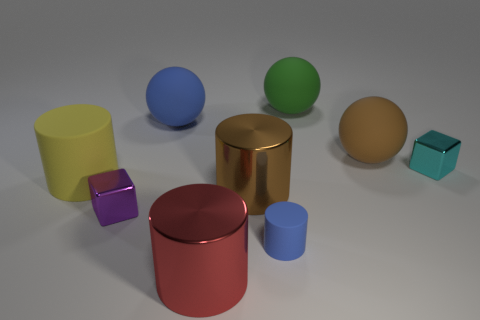How many other objects are the same color as the tiny rubber cylinder?
Offer a terse response. 1. There is a big blue sphere; are there any small rubber things to the right of it?
Your answer should be very brief. Yes. There is a metallic cube in front of the matte cylinder behind the tiny metal object that is on the left side of the large red object; what is its color?
Offer a terse response. Purple. What number of large things are both right of the large red metal cylinder and behind the yellow matte object?
Make the answer very short. 2. What number of balls are either small green rubber things or blue rubber things?
Provide a succinct answer. 1. Are any large red cylinders visible?
Offer a terse response. Yes. What number of other objects are there of the same material as the green sphere?
Give a very brief answer. 4. There is a blue object that is the same size as the red shiny object; what material is it?
Keep it short and to the point. Rubber. There is a blue rubber object that is in front of the purple metallic thing; is it the same shape as the yellow matte thing?
Your response must be concise. Yes. How many things are either shiny cubes that are to the right of the large brown cylinder or big yellow rubber blocks?
Your answer should be very brief. 1. 